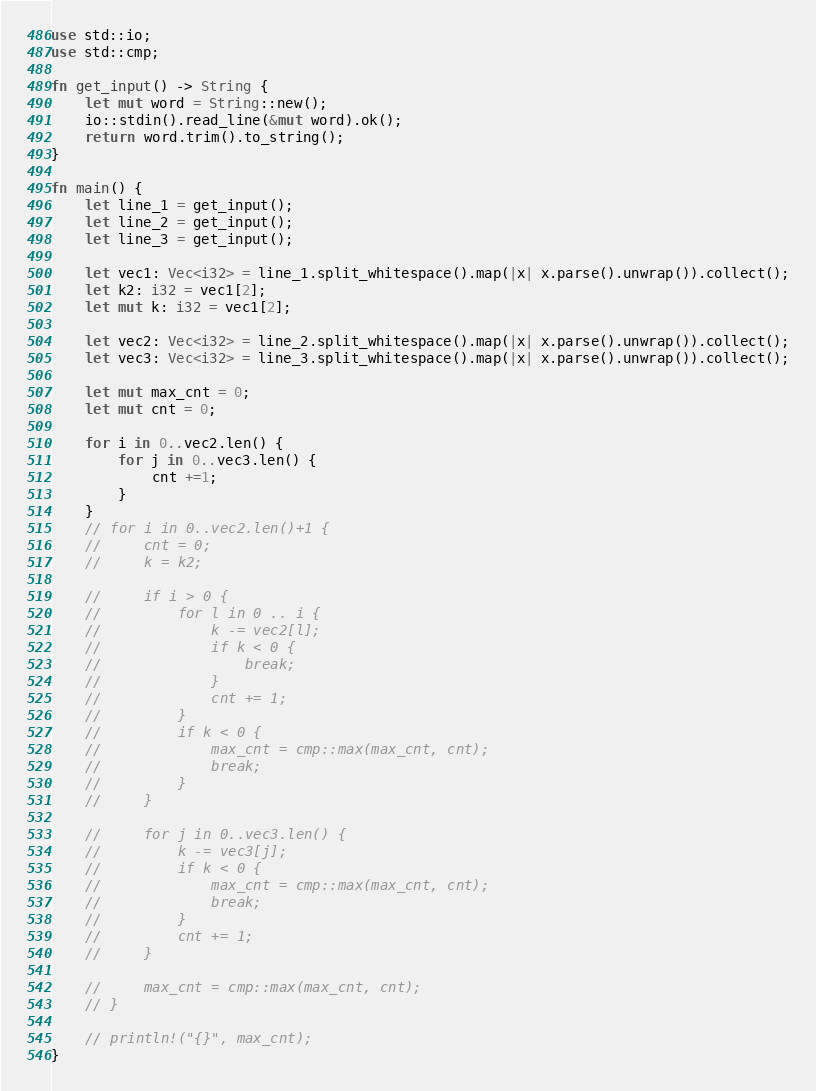<code> <loc_0><loc_0><loc_500><loc_500><_Rust_>use std::io;
use std::cmp;

fn get_input() -> String {
    let mut word = String::new();
    io::stdin().read_line(&mut word).ok();
    return word.trim().to_string();
}

fn main() {
    let line_1 = get_input();
    let line_2 = get_input();
    let line_3 = get_input();

    let vec1: Vec<i32> = line_1.split_whitespace().map(|x| x.parse().unwrap()).collect();
    let k2: i32 = vec1[2];
    let mut k: i32 = vec1[2];

    let vec2: Vec<i32> = line_2.split_whitespace().map(|x| x.parse().unwrap()).collect();
    let vec3: Vec<i32> = line_3.split_whitespace().map(|x| x.parse().unwrap()).collect();

    let mut max_cnt = 0;
    let mut cnt = 0;

    for i in 0..vec2.len() {
        for j in 0..vec3.len() {
            cnt +=1;
        }
    }
    // for i in 0..vec2.len()+1 {
    //     cnt = 0;
    //     k = k2;

    //     if i > 0 {
    //         for l in 0 .. i {
    //             k -= vec2[l];
    //             if k < 0 {
    //                 break;
    //             }
    //             cnt += 1;
    //         }
    //         if k < 0 {
    //             max_cnt = cmp::max(max_cnt, cnt);
    //             break;
    //         }     
    //     }

    //     for j in 0..vec3.len() {
    //         k -= vec3[j];
    //         if k < 0 {
    //             max_cnt = cmp::max(max_cnt, cnt);
    //             break;
    //         }
    //         cnt += 1;
    //     }

    //     max_cnt = cmp::max(max_cnt, cnt);
    // }

    // println!("{}", max_cnt);
}</code> 